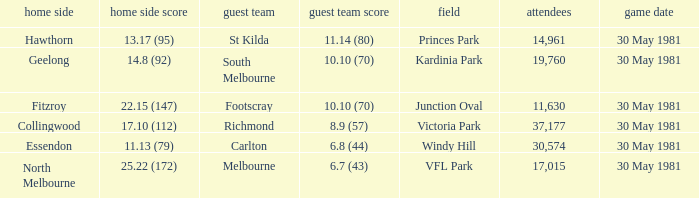What team played away at vfl park? Melbourne. 